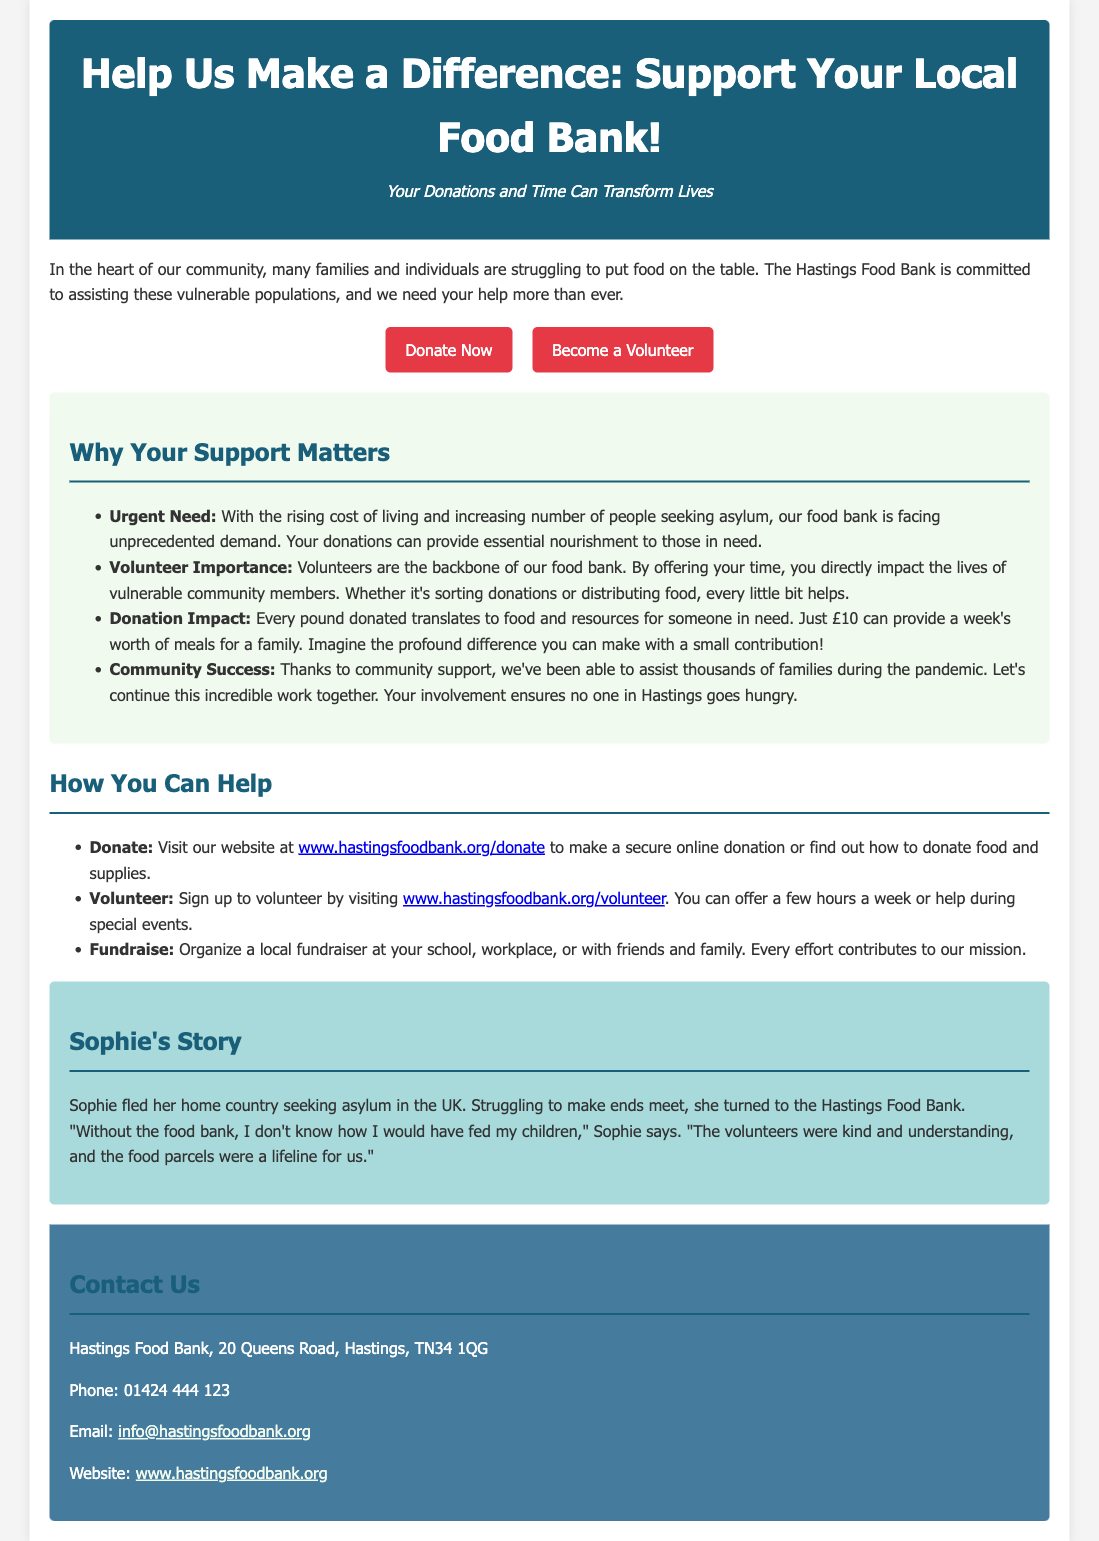What is the title of the advertisement? The title is stated at the top of the advertisement in large text.
Answer: Help Us Make a Difference: Support Your Local Food Bank! What is the urgent need mentioned in the document? The document highlights the rising cost of living and the increasing number of people seeking asylum as contributing factors to the urgent need.
Answer: Urgent Need How much can £10 provide? The document states the impact of a £10 donation in terms of meals it can supply.
Answer: A week's worth of meals for a family Who can sign up to volunteer? The document invites a specific group of people to contribute their time.
Answer: Anyone What is Sophie's situation? The advertisement shares a personal story that illustrates the food bank's impact on vulnerable individuals.
Answer: Fled her home country seeking asylum What is the food bank's phone number? The contact information includes various means for reaching the food bank, including a phone number.
Answer: 01424 444 123 What color is the header background? The color of the header is described in the styling section of the advertisement, indicating its presentation.
Answer: Dark blue Where can you find the donation link? A specific URL is provided in the document for making donations.
Answer: www.hastingsfoodbank.org/donate 